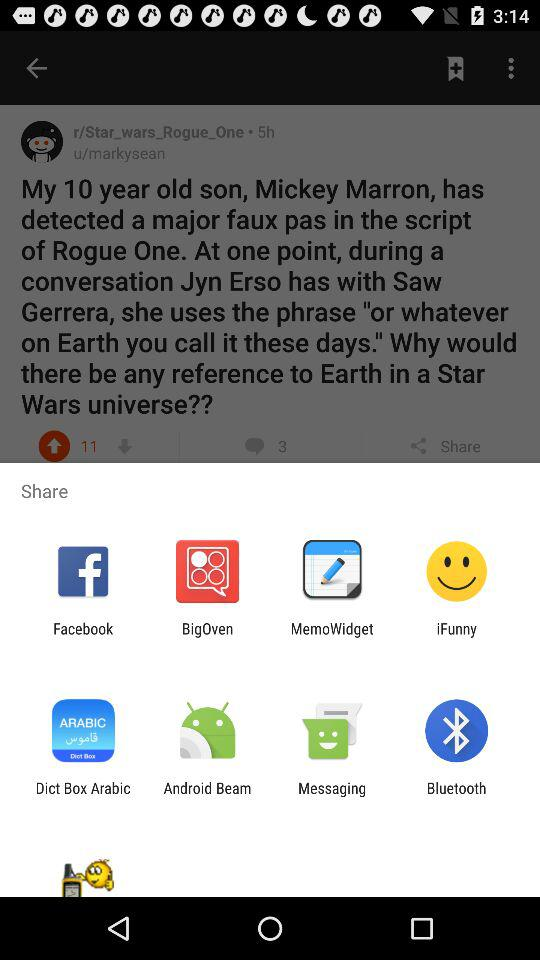Through which app can we share? You can share through "Facebook", "BigOven", "MemoWidget", "iFunny", "Dict Box Arabic", "Android Beam", "Messaging" and "Bluetooth". 